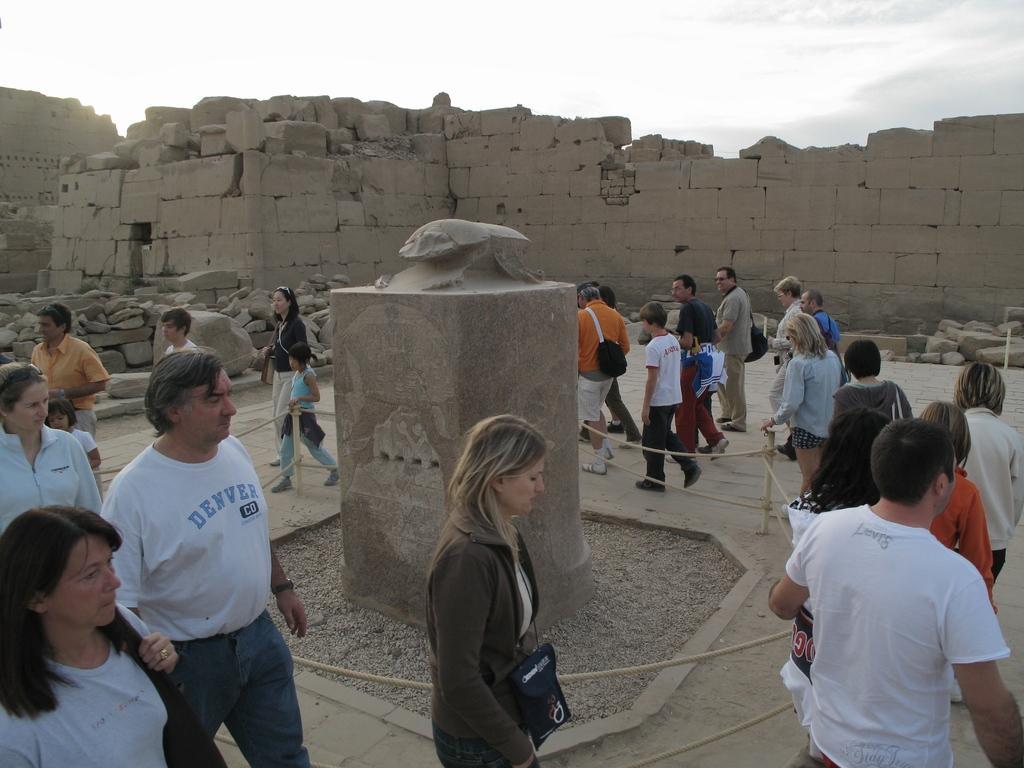Can you describe this image briefly? In this image we can see many people. There is a sculpture on a pedestal. Also there are poles with ropes. In the back there are stones. In the background there is sky with clouds. 